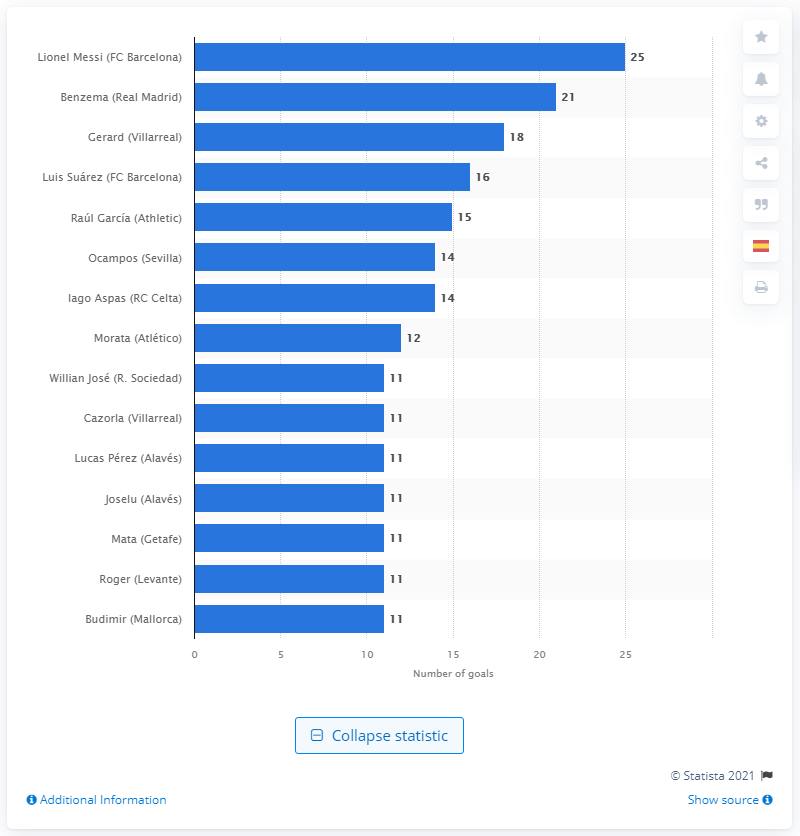Outline some significant characteristics in this image. During the 2019/2020 season, Lionel Messi scored a total of 25 goals. 